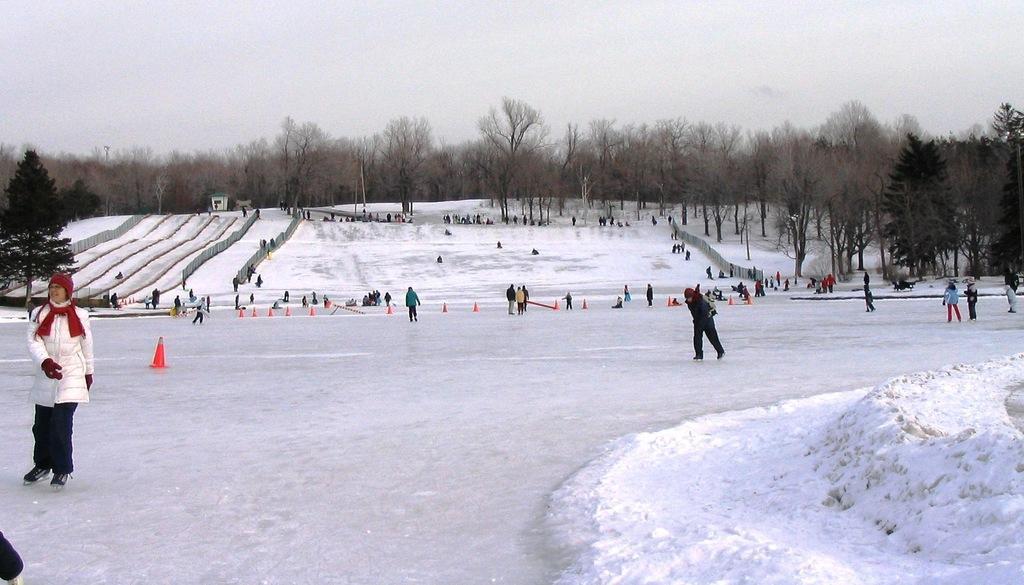Can you describe this image briefly? In this image there are persons skating on the snow. In the background there are trees and the sky is cloudy. 